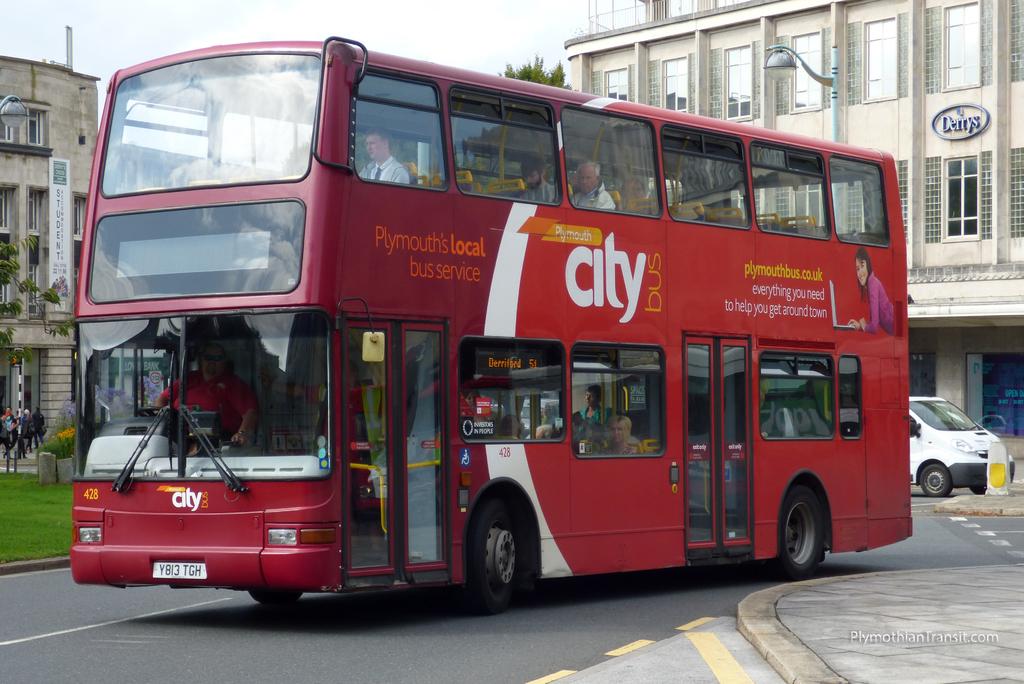What city is the bus from?
Your response must be concise. Plymouth. What is the name on the building?
Provide a short and direct response. Derrys. 